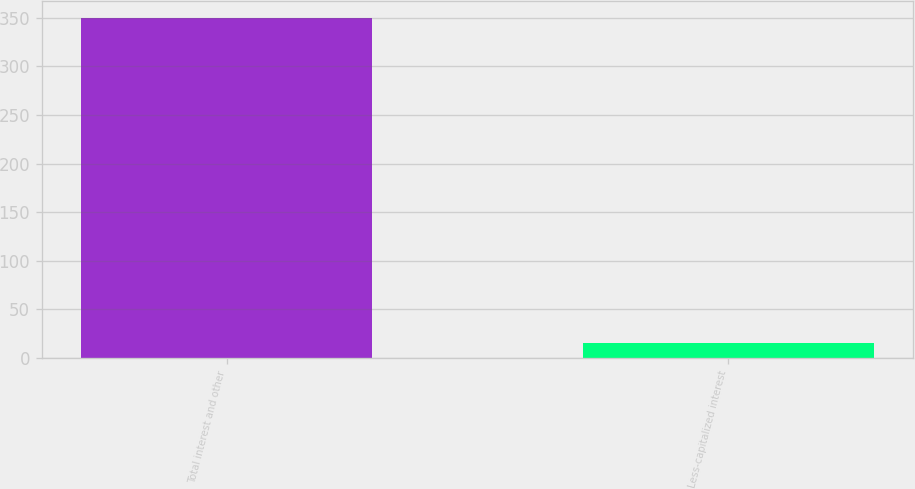Convert chart to OTSL. <chart><loc_0><loc_0><loc_500><loc_500><bar_chart><fcel>Total interest and other<fcel>Less-capitalized interest<nl><fcel>350<fcel>15<nl></chart> 